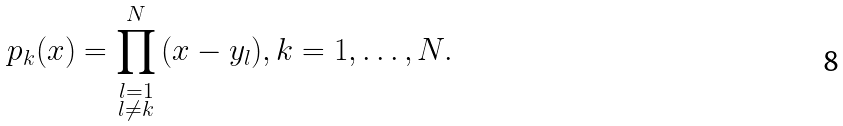<formula> <loc_0><loc_0><loc_500><loc_500>p _ { k } ( x ) = \prod _ { \substack { l = 1 \\ l \neq k } } ^ { N } \, ( x - y _ { l } ) , k = 1 , \dots , N .</formula> 